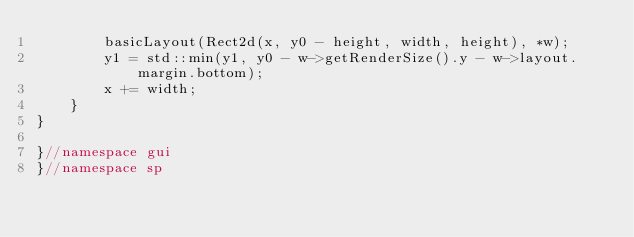Convert code to text. <code><loc_0><loc_0><loc_500><loc_500><_C++_>        basicLayout(Rect2d(x, y0 - height, width, height), *w);
        y1 = std::min(y1, y0 - w->getRenderSize().y - w->layout.margin.bottom);
        x += width;
    }
}

}//namespace gui
}//namespace sp
</code> 